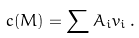Convert formula to latex. <formula><loc_0><loc_0><loc_500><loc_500>c ( M ) = \sum A _ { i } v _ { i } \, .</formula> 